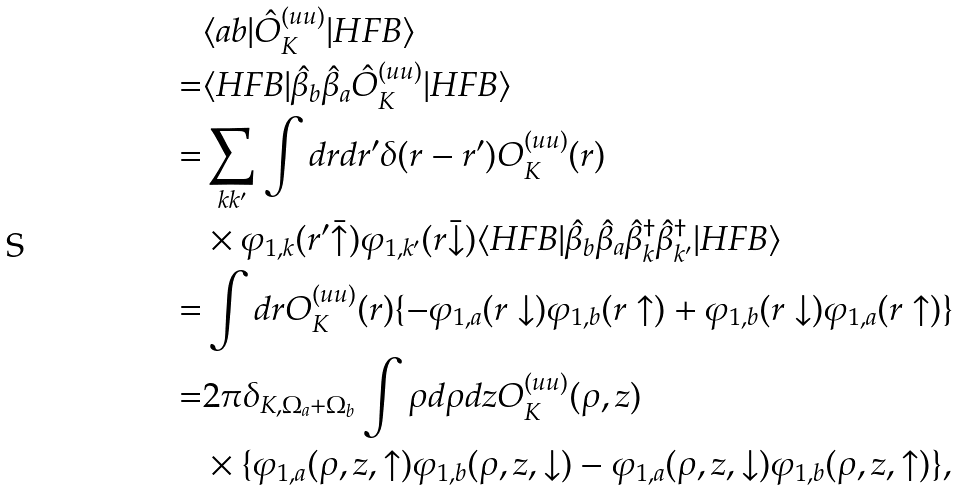<formula> <loc_0><loc_0><loc_500><loc_500>& \langle a b | \hat { O } _ { K } ^ { ( u u ) } | H F B \rangle \\ = & \langle H F B | \hat { \beta } _ { b } \hat { \beta } _ { a } \hat { O } _ { K } ^ { ( u u ) } | H F B \rangle \\ = & \sum _ { k k ^ { \prime } } \int d r d r ^ { \prime } \delta ( r - r ^ { \prime } ) O ^ { ( u u ) } _ { K } ( r ) \\ & \times \varphi _ { 1 , k } ( r ^ { \prime } \bar { \uparrow } ) \varphi _ { 1 , k ^ { \prime } } ( r \bar { \downarrow } ) \langle H F B | \hat { \beta } _ { b } \hat { \beta } _ { a } \hat { \beta } ^ { \dagger } _ { k } \hat { \beta } ^ { \dagger } _ { k ^ { \prime } } | H F B \rangle \\ = & \int d r O ^ { ( u u ) } _ { K } ( r ) \{ - \varphi _ { 1 , a } ( r \downarrow ) \varphi _ { 1 , b } ( r \uparrow ) + \varphi _ { 1 , b } ( r \downarrow ) \varphi _ { 1 , a } ( r \uparrow ) \} \\ = & 2 \pi \delta _ { K , \Omega _ { a } + \Omega _ { b } } \int \rho d \rho d z O ^ { ( u u ) } _ { K } ( \rho , z ) \\ & \times \{ \varphi _ { 1 , a } ( \rho , z , \uparrow ) \varphi _ { 1 , b } ( \rho , z , \downarrow ) - \varphi _ { 1 , a } ( \rho , z , \downarrow ) \varphi _ { 1 , b } ( \rho , z , \uparrow ) \} ,</formula> 